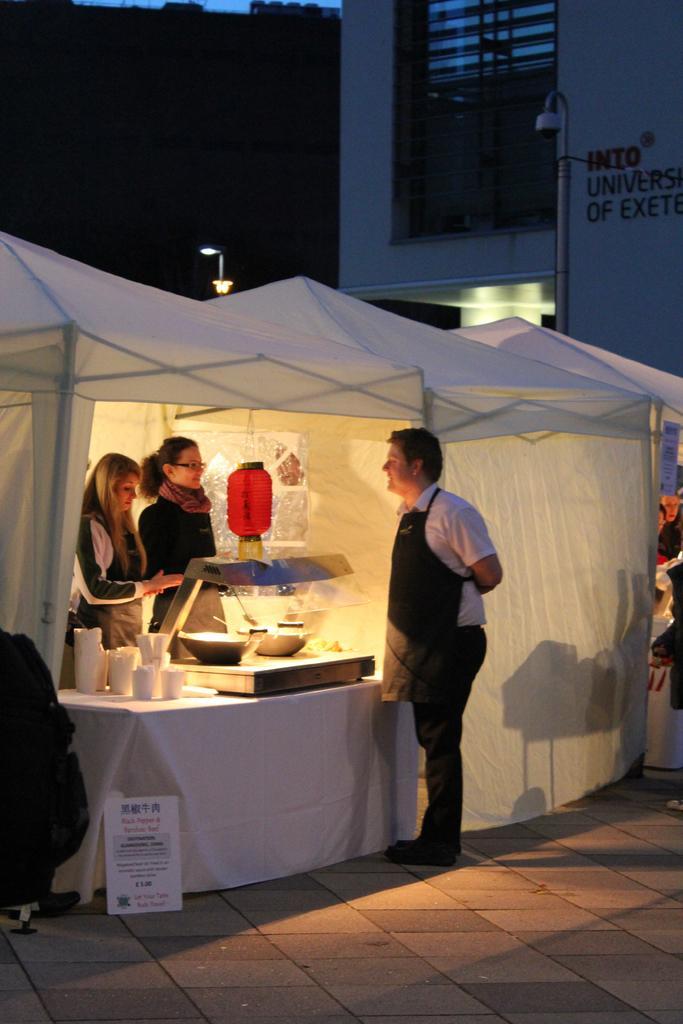Describe this image in one or two sentences. In this picture we can see group of people two women are standing in the tent in front of a machine, in the background we can see couple of lights and a building. 